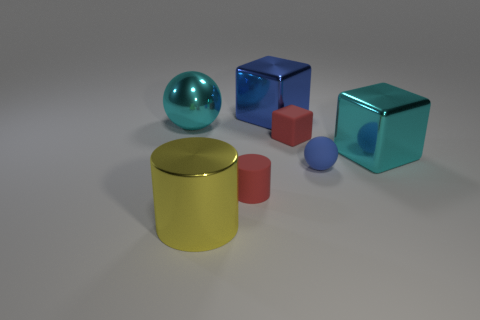Add 3 large cyan spheres. How many objects exist? 10 Subtract all blocks. How many objects are left? 4 Add 3 big cyan things. How many big cyan things are left? 5 Add 2 small objects. How many small objects exist? 5 Subtract 0 yellow blocks. How many objects are left? 7 Subtract all brown rubber cubes. Subtract all small blue matte things. How many objects are left? 6 